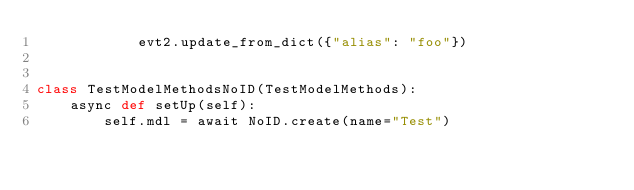<code> <loc_0><loc_0><loc_500><loc_500><_Python_>            evt2.update_from_dict({"alias": "foo"})


class TestModelMethodsNoID(TestModelMethods):
    async def setUp(self):
        self.mdl = await NoID.create(name="Test")</code> 